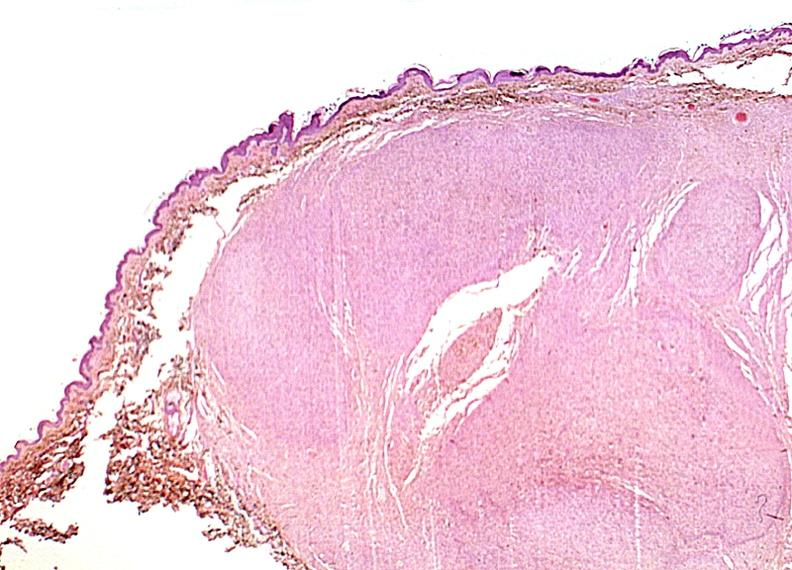does ulcer show skin, neurofibromatosis?
Answer the question using a single word or phrase. No 